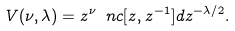Convert formula to latex. <formula><loc_0><loc_0><loc_500><loc_500>V ( \nu , \lambda ) = z ^ { \nu } \ n c [ z , z ^ { - 1 } ] d z ^ { - \lambda / 2 } .</formula> 